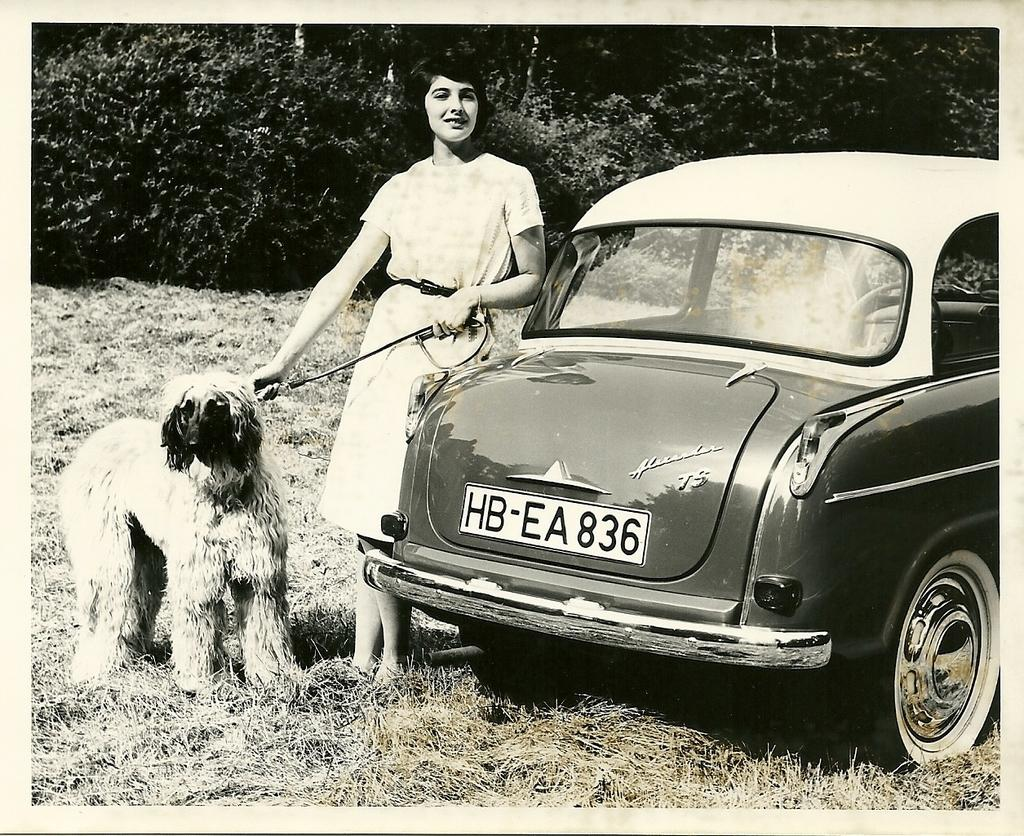What is the color scheme of the image? The image is black and white. What type of natural environment can be seen in the image? There are trees in the background of the image, and grass is visible in the image. What type of vehicle is present in the image? There is a car in the image. Who is present in the image, and what are they doing? A woman is standing in the image, and she is holding a dog's leash. What type of plastic material can be seen in the image? There is no plastic material present in the image. What type of spark can be seen coming from the trees in the image? There is no spark visible in the image; the trees are not on fire or producing any sparks. 